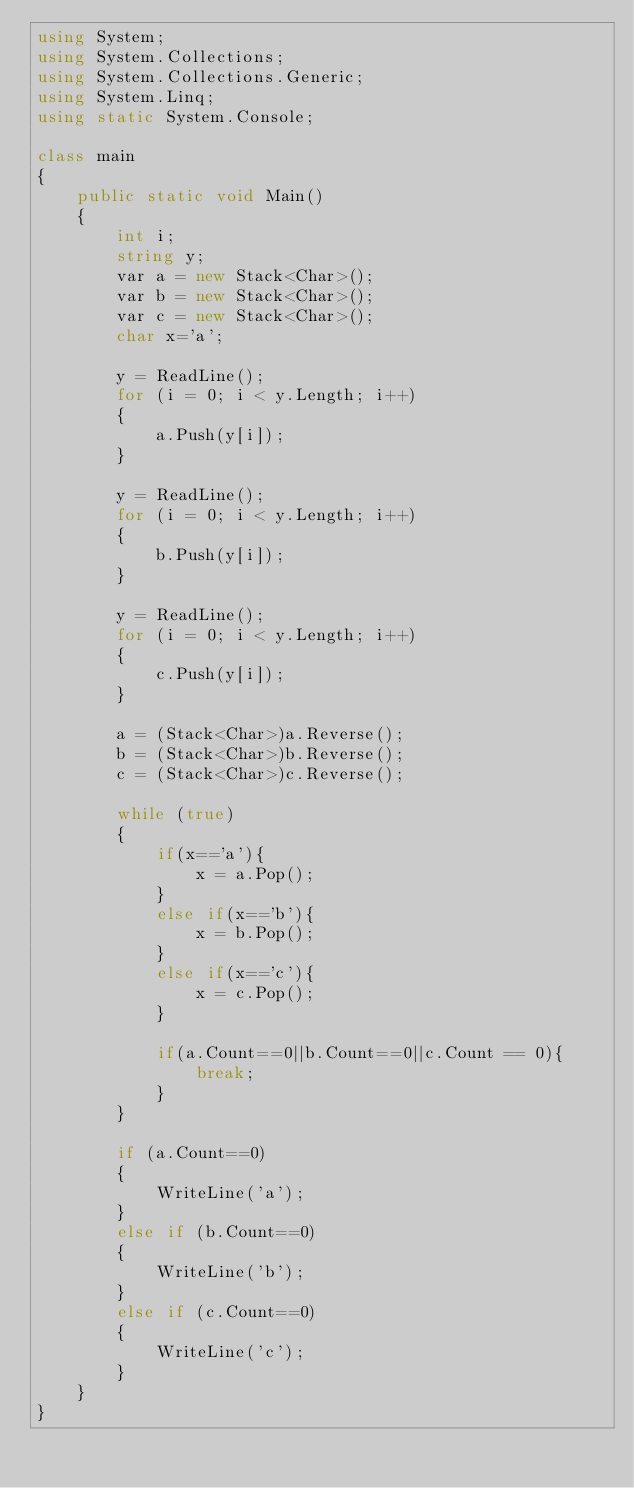Convert code to text. <code><loc_0><loc_0><loc_500><loc_500><_C#_>using System;
using System.Collections;
using System.Collections.Generic;
using System.Linq;
using static System.Console;

class main
{
    public static void Main()
    {
        int i;
        string y;
        var a = new Stack<Char>();
        var b = new Stack<Char>();
        var c = new Stack<Char>();
        char x='a';

        y = ReadLine();
        for (i = 0; i < y.Length; i++)
        {
            a.Push(y[i]);
        }

        y = ReadLine();
        for (i = 0; i < y.Length; i++)
        {
            b.Push(y[i]);
        }

        y = ReadLine();
        for (i = 0; i < y.Length; i++)
        {
            c.Push(y[i]);
        }

        a = (Stack<Char>)a.Reverse();
        b = (Stack<Char>)b.Reverse();
        c = (Stack<Char>)c.Reverse();

        while (true)
        {
            if(x=='a'){
                x = a.Pop();
            }
            else if(x=='b'){
                x = b.Pop();
            }
            else if(x=='c'){
                x = c.Pop();
            }

            if(a.Count==0||b.Count==0||c.Count == 0){
                break;
            }
        }

        if (a.Count==0)
        {
            WriteLine('a');
        }
        else if (b.Count==0)
        {
            WriteLine('b');
        }
        else if (c.Count==0)
        {
            WriteLine('c');
        }
    }
}</code> 